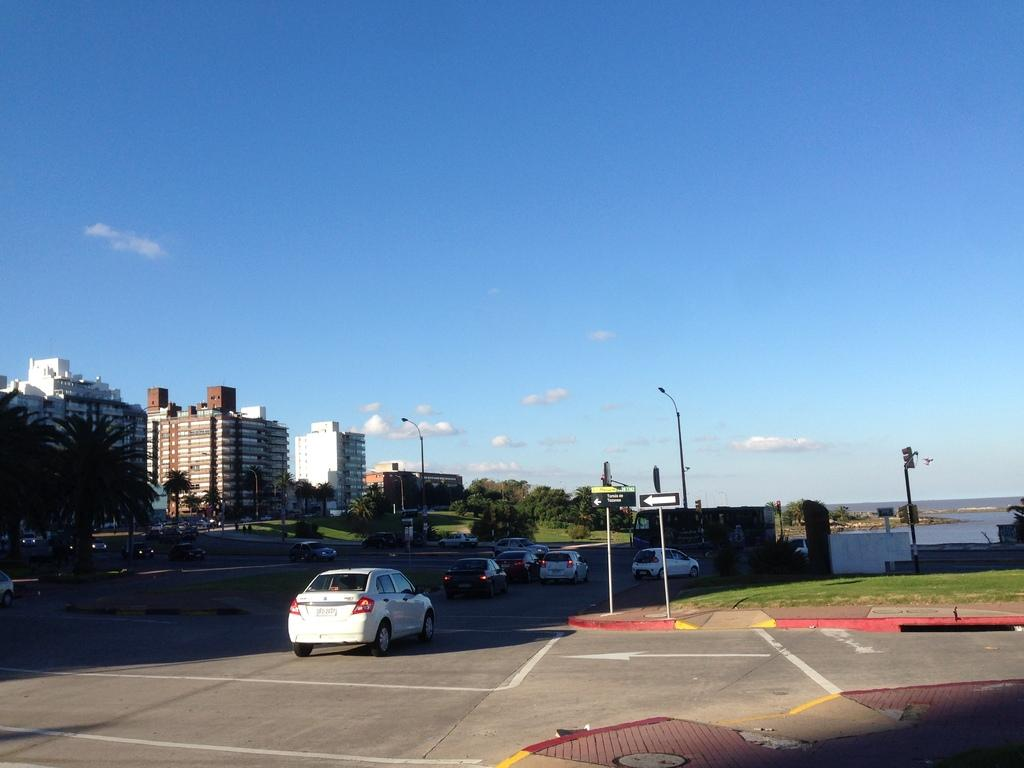What can be seen on the road in the image? There are vehicles on the road in the image. What helps regulate traffic in the image? There are road signals in the image. What type of vegetation is visible in the image? Grass and trees are visible in the image. What is the source of light on the electric poles in the image? There are lights on electric poles in the image. What is the body of water visible in the image? Water is visible in the image. What can be seen in the sky in the image? There are clouds in the sky in the image. What is the purpose of the bear in the image? There is no bear present in the image, so it does not serve any purpose in the context of the image. 